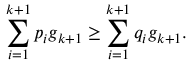Convert formula to latex. <formula><loc_0><loc_0><loc_500><loc_500>\sum _ { i = 1 } ^ { k + 1 } p _ { i } g _ { k + 1 } \geq \sum _ { i = 1 } ^ { k + 1 } q _ { i } g _ { k + 1 } .</formula> 